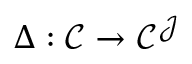<formula> <loc_0><loc_0><loc_500><loc_500>\Delta \colon { \mathcal { C } } \to { \mathcal { C } } ^ { \mathcal { J } }</formula> 